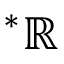Convert formula to latex. <formula><loc_0><loc_0><loc_500><loc_500>{ } ^ { \ast } \mathbb { R }</formula> 